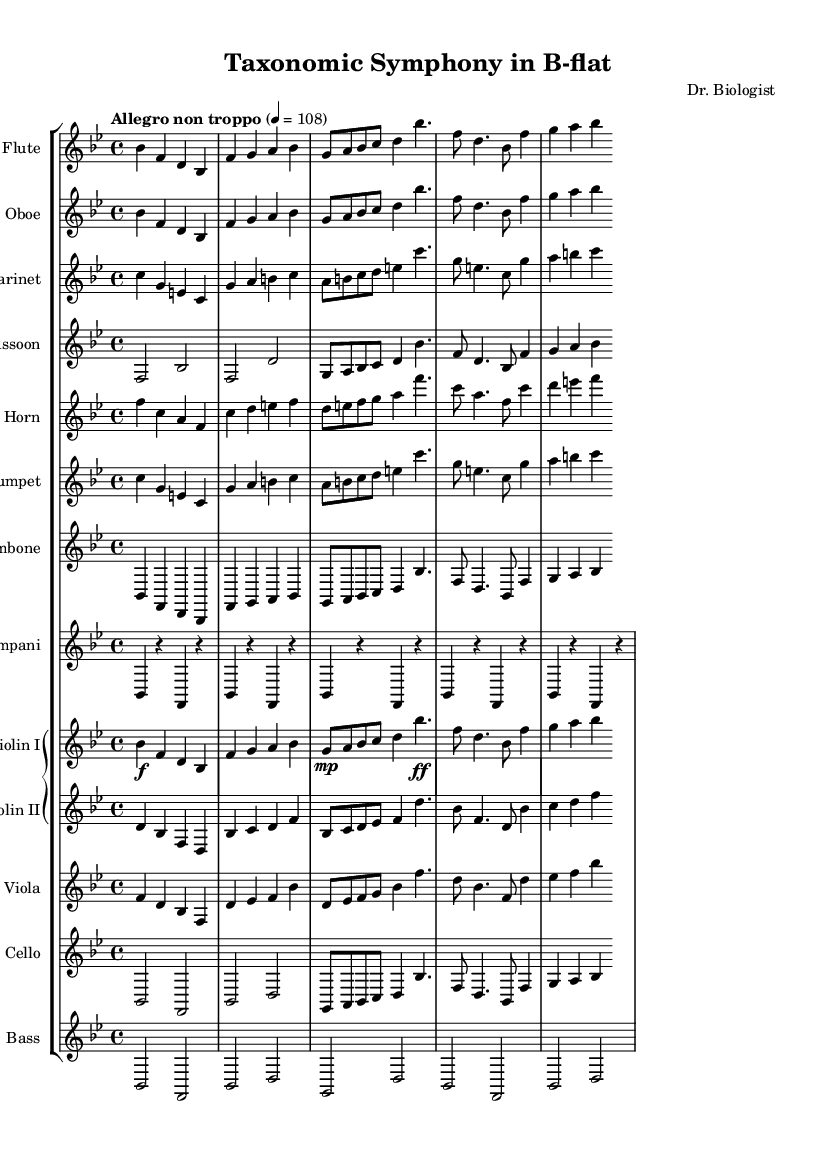What is the key signature of this music? The key signature is B-flat major, which has two flats (B-flat and E-flat). This can be determined by examining the key signature at the beginning of the sheet music.
Answer: B-flat major What is the time signature of this piece? The time signature is 4/4, which indicates four beats per measure and a quarter note receives one beat. This can be identified directly from the time signature notation located in the staff system.
Answer: 4/4 What tempo marking is indicated for this symphony? The tempo marking is "Allegro non troppo," which suggests a fast but not excessively fast pace. This is located at the beginning of the score, just above the staff.
Answer: Allegro non troppo Which instruments are featured in the first measure? The first measure features Flute, Oboe, Clarinet, Bassoon, Horn, Trumpet, Trombone, Timpani, Violin I, Violin II, Viola, Cello, and Bass. This can be confirmed by reviewing the top line of the music for the instrument names as part of the staff group.
Answer: Flute, Oboe, Clarinet, Bassoon, Horn, Trumpet, Trombone, Timpani, Violin I, Violin II, Viola, Cello, Bass How many instruments are transposed in this symphony? There are three instruments that are transposed: Clarinet (B-flat), Horn (F), and Trumpet (B-flat). This is determined by looking for the mentioned transpositions in the individual parts indicated in the score.
Answer: Three instruments What motif does the cello use in the second measure? The motif in the cello part is a sequence of notes starting from B-flat, moving to F, B-flat, and then D. Analyzing the second measure of the cello staff reveals this melodic line that constitutes the motif.
Answer: B-flat, F, B-flat, D 